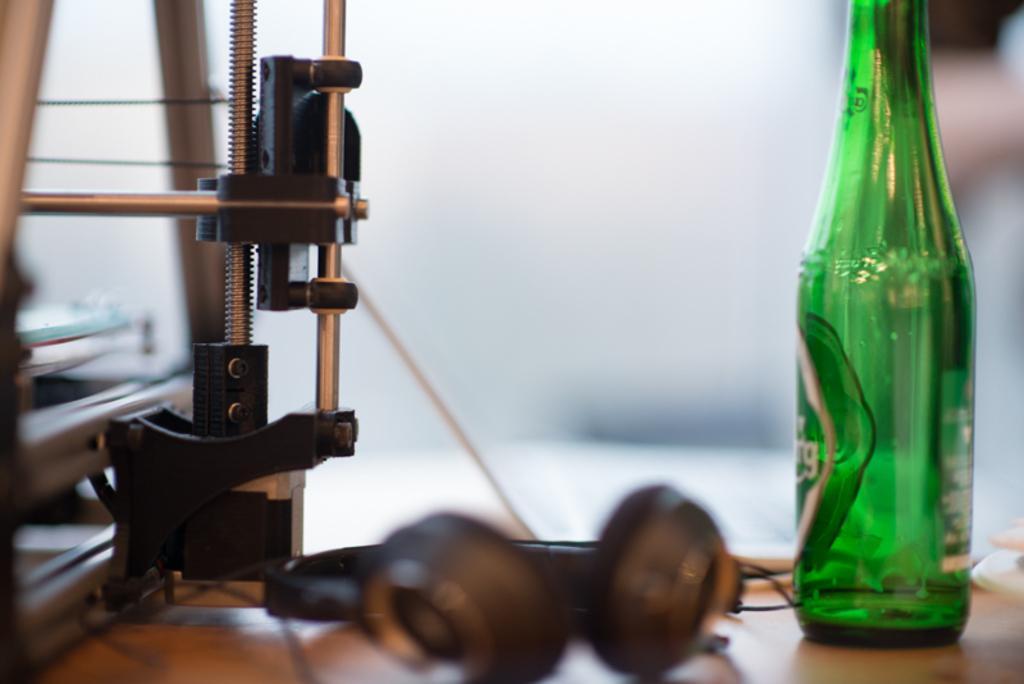How would you summarize this image in a sentence or two? Background is completely blur. Here we can see equipment, headsets and green colour bottle on the table. 